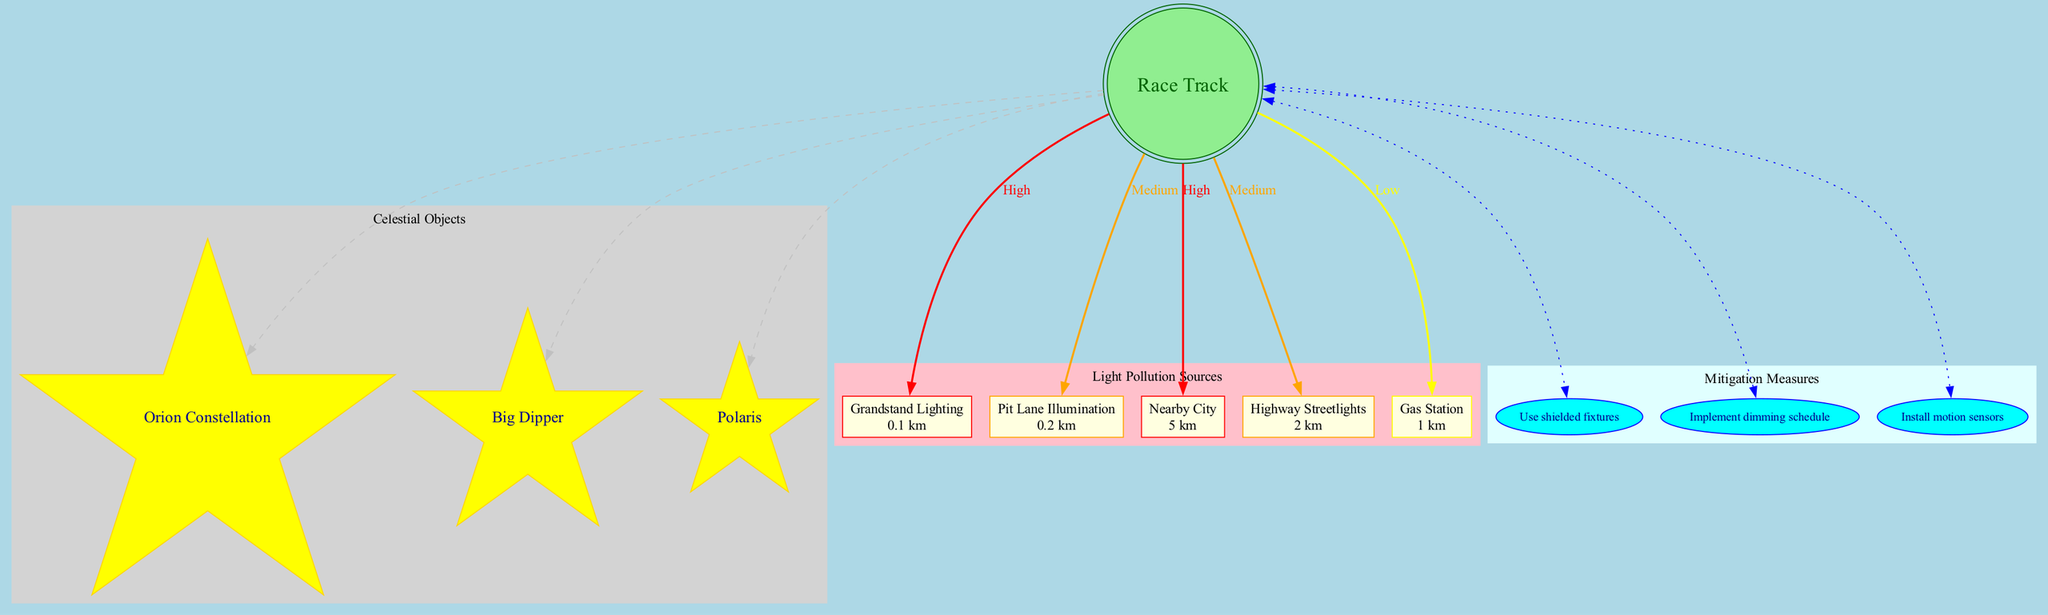What celestial object is shown closest to the race track? The diagram indicates that "Orion Constellation" is connected to the race track, which suggests it is the closest celestial object depicted.
Answer: Orion Constellation How many light pollution sources are identified in the diagram? By counting the nodes labeled as light pollution sources in the diagram, there are five distinct sources listed.
Answer: 5 Which light pollution source is labeled as having a 'High' impact? The sources "Grandstand Lighting" and "Nearby City" are both marked with a 'High' impact, as indicated by their color coding and labels.
Answer: Grandstand Lighting, Nearby City What mitigation measure is indicated in the diagram? The diagram includes several nodes representing mitigation measures, such as "Use shielded fixtures", which is one of the strategies presented to reduce light pollution.
Answer: Use shielded fixtures Which source is the farthest from the race track and what is its impact? The "Nearby City" is listed at a distance of 5 km from the race track and is marked with a 'High' impact, as shown in the diagram connections and labels.
Answer: Nearby City, High How many celestial objects are depicted in the diagram? There are three celestial objects in the diagram: "Orion Constellation", "Big Dipper", and "Polaris", which can be directly counted from the labeled nodes.
Answer: 3 What color is used for sources with a 'Medium' impact? The sources with a 'Medium' impact are represented with an orange color according to the color-coding scheme presented in the diagram.
Answer: Orange Which mitigation measure is indicated to install motion sensors? One of the mitigation measures listed in the diagram is "Install motion sensors", which addresses the need for reducing light pollution and is shown as an identifiable node.
Answer: Install motion sensors What is the distance of the Pit Lane Illumination from the race track? The diagram specifies the distance for "Pit Lane Illumination" as 0.2 km, which can be found on the respective node for that light pollution source.
Answer: 0.2 km 